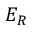<formula> <loc_0><loc_0><loc_500><loc_500>E _ { R }</formula> 